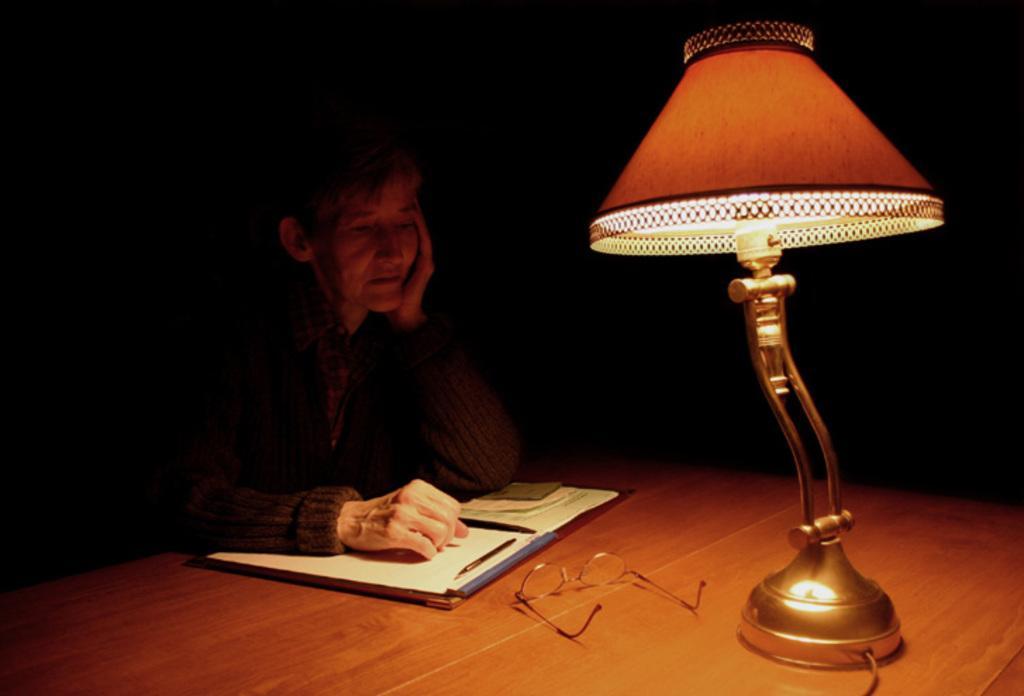How would you summarize this image in a sentence or two? In this picture there is a person sitting and there is a table in front of him which has few papers,spectacles and some other objects on it and there is a lamp in the right corner. 